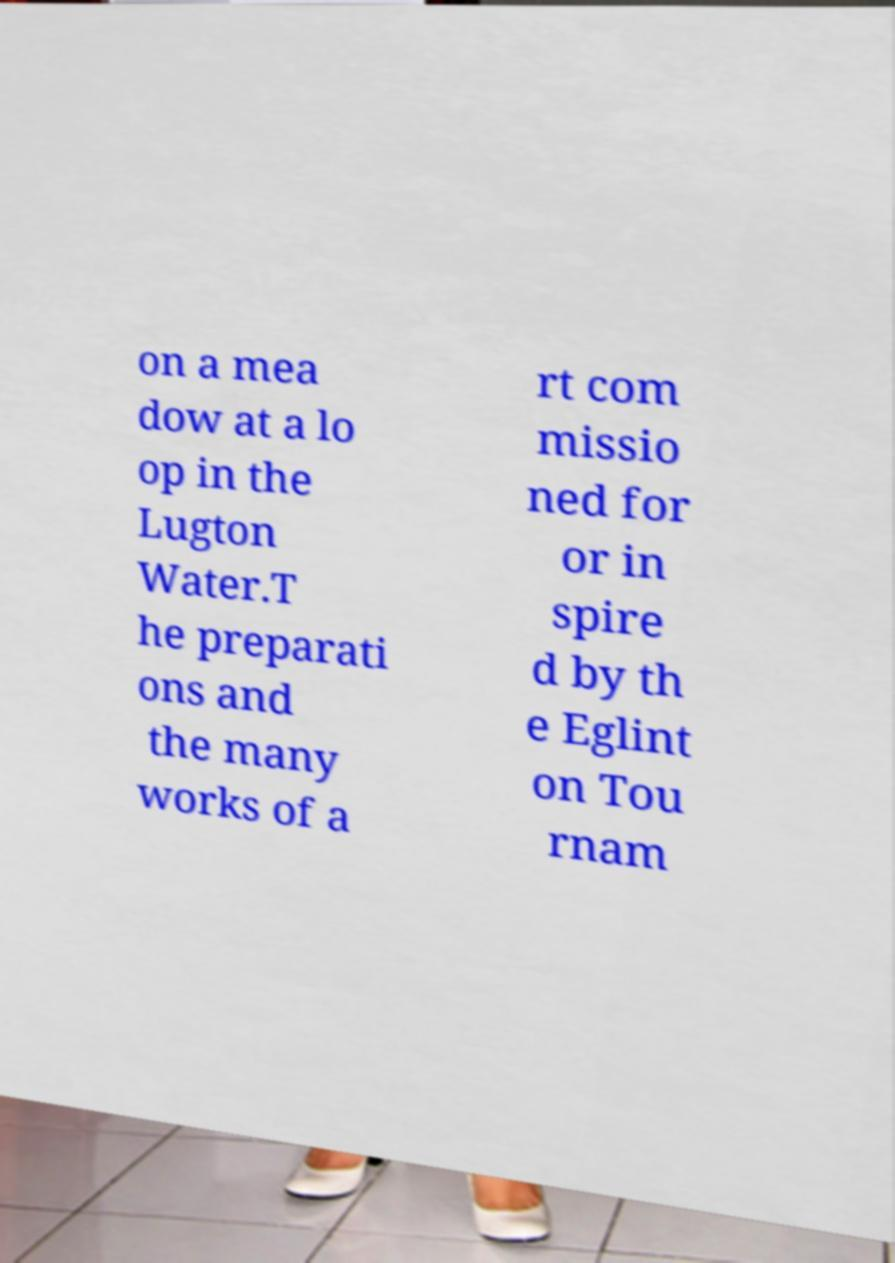Could you assist in decoding the text presented in this image and type it out clearly? on a mea dow at a lo op in the Lugton Water.T he preparati ons and the many works of a rt com missio ned for or in spire d by th e Eglint on Tou rnam 